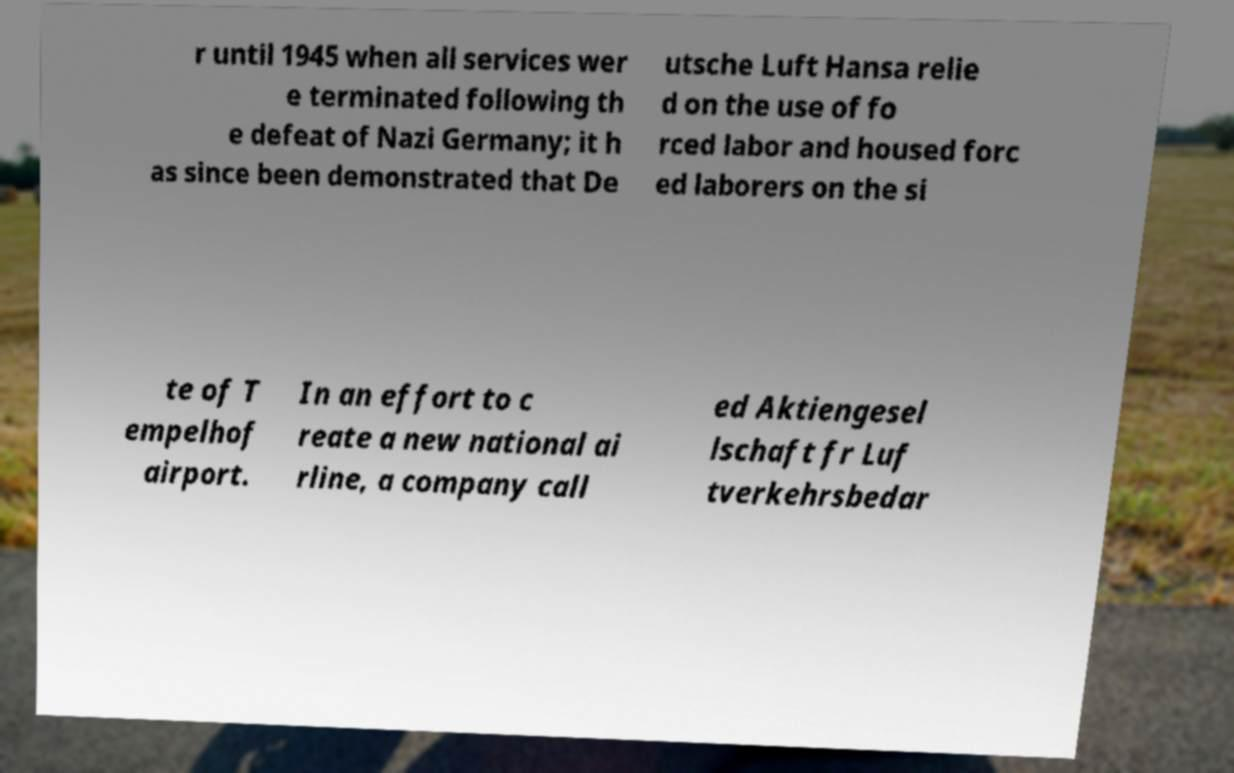I need the written content from this picture converted into text. Can you do that? r until 1945 when all services wer e terminated following th e defeat of Nazi Germany; it h as since been demonstrated that De utsche Luft Hansa relie d on the use of fo rced labor and housed forc ed laborers on the si te of T empelhof airport. In an effort to c reate a new national ai rline, a company call ed Aktiengesel lschaft fr Luf tverkehrsbedar 